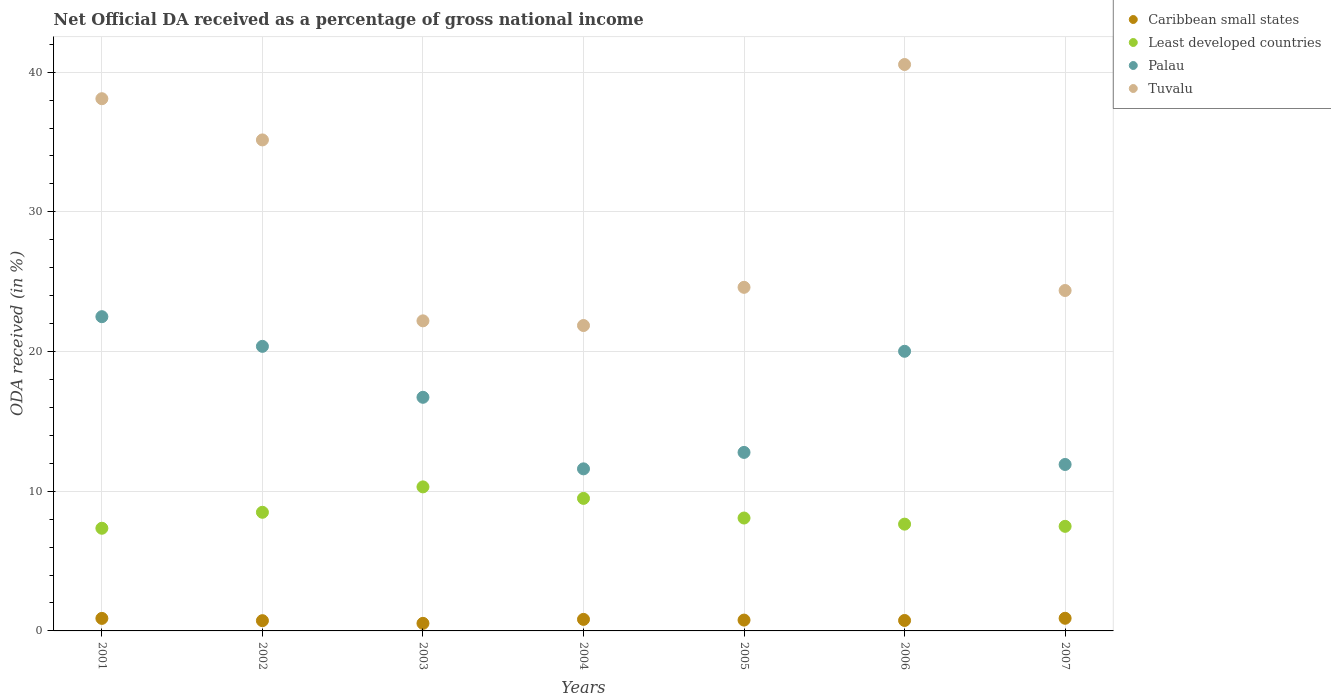Is the number of dotlines equal to the number of legend labels?
Keep it short and to the point. Yes. What is the net official DA received in Tuvalu in 2003?
Keep it short and to the point. 22.2. Across all years, what is the maximum net official DA received in Least developed countries?
Your answer should be compact. 10.31. Across all years, what is the minimum net official DA received in Least developed countries?
Your answer should be very brief. 7.35. What is the total net official DA received in Tuvalu in the graph?
Your answer should be very brief. 206.83. What is the difference between the net official DA received in Tuvalu in 2001 and that in 2005?
Offer a very short reply. 13.5. What is the difference between the net official DA received in Caribbean small states in 2002 and the net official DA received in Least developed countries in 2003?
Your response must be concise. -9.58. What is the average net official DA received in Tuvalu per year?
Your answer should be very brief. 29.55. In the year 2002, what is the difference between the net official DA received in Tuvalu and net official DA received in Palau?
Offer a terse response. 14.78. What is the ratio of the net official DA received in Least developed countries in 2003 to that in 2007?
Your response must be concise. 1.38. What is the difference between the highest and the second highest net official DA received in Caribbean small states?
Offer a terse response. 0.01. What is the difference between the highest and the lowest net official DA received in Tuvalu?
Give a very brief answer. 18.69. Is it the case that in every year, the sum of the net official DA received in Least developed countries and net official DA received in Caribbean small states  is greater than the net official DA received in Tuvalu?
Make the answer very short. No. How many dotlines are there?
Your answer should be compact. 4. Are the values on the major ticks of Y-axis written in scientific E-notation?
Your answer should be very brief. No. Does the graph contain any zero values?
Your response must be concise. No. How many legend labels are there?
Provide a short and direct response. 4. What is the title of the graph?
Your answer should be compact. Net Official DA received as a percentage of gross national income. Does "Gambia, The" appear as one of the legend labels in the graph?
Ensure brevity in your answer.  No. What is the label or title of the Y-axis?
Offer a very short reply. ODA received (in %). What is the ODA received (in %) of Caribbean small states in 2001?
Give a very brief answer. 0.9. What is the ODA received (in %) of Least developed countries in 2001?
Offer a terse response. 7.35. What is the ODA received (in %) in Palau in 2001?
Offer a terse response. 22.5. What is the ODA received (in %) of Tuvalu in 2001?
Keep it short and to the point. 38.1. What is the ODA received (in %) of Caribbean small states in 2002?
Your answer should be very brief. 0.73. What is the ODA received (in %) in Least developed countries in 2002?
Your answer should be very brief. 8.49. What is the ODA received (in %) in Palau in 2002?
Give a very brief answer. 20.37. What is the ODA received (in %) of Tuvalu in 2002?
Offer a terse response. 35.15. What is the ODA received (in %) in Caribbean small states in 2003?
Provide a succinct answer. 0.54. What is the ODA received (in %) of Least developed countries in 2003?
Offer a very short reply. 10.31. What is the ODA received (in %) of Palau in 2003?
Provide a succinct answer. 16.73. What is the ODA received (in %) in Tuvalu in 2003?
Keep it short and to the point. 22.2. What is the ODA received (in %) in Caribbean small states in 2004?
Your response must be concise. 0.83. What is the ODA received (in %) in Least developed countries in 2004?
Offer a very short reply. 9.49. What is the ODA received (in %) of Palau in 2004?
Offer a terse response. 11.6. What is the ODA received (in %) in Tuvalu in 2004?
Your answer should be compact. 21.86. What is the ODA received (in %) in Caribbean small states in 2005?
Give a very brief answer. 0.78. What is the ODA received (in %) of Least developed countries in 2005?
Your response must be concise. 8.08. What is the ODA received (in %) of Palau in 2005?
Offer a very short reply. 12.78. What is the ODA received (in %) of Tuvalu in 2005?
Give a very brief answer. 24.6. What is the ODA received (in %) in Caribbean small states in 2006?
Offer a very short reply. 0.75. What is the ODA received (in %) in Least developed countries in 2006?
Your answer should be very brief. 7.64. What is the ODA received (in %) in Palau in 2006?
Offer a very short reply. 20.02. What is the ODA received (in %) of Tuvalu in 2006?
Provide a short and direct response. 40.55. What is the ODA received (in %) of Caribbean small states in 2007?
Keep it short and to the point. 0.91. What is the ODA received (in %) of Least developed countries in 2007?
Make the answer very short. 7.49. What is the ODA received (in %) of Palau in 2007?
Provide a succinct answer. 11.92. What is the ODA received (in %) in Tuvalu in 2007?
Offer a terse response. 24.37. Across all years, what is the maximum ODA received (in %) of Caribbean small states?
Ensure brevity in your answer.  0.91. Across all years, what is the maximum ODA received (in %) in Least developed countries?
Your answer should be compact. 10.31. Across all years, what is the maximum ODA received (in %) in Palau?
Your response must be concise. 22.5. Across all years, what is the maximum ODA received (in %) of Tuvalu?
Make the answer very short. 40.55. Across all years, what is the minimum ODA received (in %) in Caribbean small states?
Your response must be concise. 0.54. Across all years, what is the minimum ODA received (in %) of Least developed countries?
Keep it short and to the point. 7.35. Across all years, what is the minimum ODA received (in %) of Palau?
Keep it short and to the point. 11.6. Across all years, what is the minimum ODA received (in %) in Tuvalu?
Offer a terse response. 21.86. What is the total ODA received (in %) of Caribbean small states in the graph?
Keep it short and to the point. 5.43. What is the total ODA received (in %) of Least developed countries in the graph?
Ensure brevity in your answer.  58.86. What is the total ODA received (in %) in Palau in the graph?
Offer a very short reply. 115.91. What is the total ODA received (in %) in Tuvalu in the graph?
Provide a short and direct response. 206.83. What is the difference between the ODA received (in %) of Caribbean small states in 2001 and that in 2002?
Your response must be concise. 0.16. What is the difference between the ODA received (in %) of Least developed countries in 2001 and that in 2002?
Offer a very short reply. -1.14. What is the difference between the ODA received (in %) of Palau in 2001 and that in 2002?
Offer a very short reply. 2.12. What is the difference between the ODA received (in %) of Tuvalu in 2001 and that in 2002?
Provide a succinct answer. 2.95. What is the difference between the ODA received (in %) in Caribbean small states in 2001 and that in 2003?
Give a very brief answer. 0.35. What is the difference between the ODA received (in %) in Least developed countries in 2001 and that in 2003?
Provide a succinct answer. -2.96. What is the difference between the ODA received (in %) in Palau in 2001 and that in 2003?
Keep it short and to the point. 5.77. What is the difference between the ODA received (in %) in Tuvalu in 2001 and that in 2003?
Make the answer very short. 15.9. What is the difference between the ODA received (in %) in Caribbean small states in 2001 and that in 2004?
Offer a terse response. 0.07. What is the difference between the ODA received (in %) in Least developed countries in 2001 and that in 2004?
Keep it short and to the point. -2.14. What is the difference between the ODA received (in %) of Palau in 2001 and that in 2004?
Provide a short and direct response. 10.89. What is the difference between the ODA received (in %) in Tuvalu in 2001 and that in 2004?
Keep it short and to the point. 16.24. What is the difference between the ODA received (in %) in Caribbean small states in 2001 and that in 2005?
Give a very brief answer. 0.12. What is the difference between the ODA received (in %) in Least developed countries in 2001 and that in 2005?
Offer a terse response. -0.73. What is the difference between the ODA received (in %) in Palau in 2001 and that in 2005?
Your answer should be very brief. 9.72. What is the difference between the ODA received (in %) of Tuvalu in 2001 and that in 2005?
Ensure brevity in your answer.  13.5. What is the difference between the ODA received (in %) in Caribbean small states in 2001 and that in 2006?
Offer a terse response. 0.15. What is the difference between the ODA received (in %) of Least developed countries in 2001 and that in 2006?
Your answer should be compact. -0.29. What is the difference between the ODA received (in %) of Palau in 2001 and that in 2006?
Make the answer very short. 2.48. What is the difference between the ODA received (in %) of Tuvalu in 2001 and that in 2006?
Your answer should be very brief. -2.45. What is the difference between the ODA received (in %) of Caribbean small states in 2001 and that in 2007?
Provide a succinct answer. -0.01. What is the difference between the ODA received (in %) of Least developed countries in 2001 and that in 2007?
Your answer should be very brief. -0.14. What is the difference between the ODA received (in %) of Palau in 2001 and that in 2007?
Offer a very short reply. 10.58. What is the difference between the ODA received (in %) in Tuvalu in 2001 and that in 2007?
Ensure brevity in your answer.  13.73. What is the difference between the ODA received (in %) of Caribbean small states in 2002 and that in 2003?
Keep it short and to the point. 0.19. What is the difference between the ODA received (in %) in Least developed countries in 2002 and that in 2003?
Offer a terse response. -1.82. What is the difference between the ODA received (in %) in Palau in 2002 and that in 2003?
Give a very brief answer. 3.65. What is the difference between the ODA received (in %) of Tuvalu in 2002 and that in 2003?
Make the answer very short. 12.95. What is the difference between the ODA received (in %) of Caribbean small states in 2002 and that in 2004?
Your answer should be compact. -0.09. What is the difference between the ODA received (in %) in Least developed countries in 2002 and that in 2004?
Provide a succinct answer. -1. What is the difference between the ODA received (in %) in Palau in 2002 and that in 2004?
Your answer should be very brief. 8.77. What is the difference between the ODA received (in %) of Tuvalu in 2002 and that in 2004?
Provide a short and direct response. 13.29. What is the difference between the ODA received (in %) of Caribbean small states in 2002 and that in 2005?
Your response must be concise. -0.04. What is the difference between the ODA received (in %) in Least developed countries in 2002 and that in 2005?
Provide a succinct answer. 0.41. What is the difference between the ODA received (in %) in Palau in 2002 and that in 2005?
Ensure brevity in your answer.  7.59. What is the difference between the ODA received (in %) in Tuvalu in 2002 and that in 2005?
Keep it short and to the point. 10.55. What is the difference between the ODA received (in %) in Caribbean small states in 2002 and that in 2006?
Provide a short and direct response. -0.01. What is the difference between the ODA received (in %) of Least developed countries in 2002 and that in 2006?
Give a very brief answer. 0.85. What is the difference between the ODA received (in %) in Palau in 2002 and that in 2006?
Offer a terse response. 0.35. What is the difference between the ODA received (in %) in Tuvalu in 2002 and that in 2006?
Your answer should be compact. -5.4. What is the difference between the ODA received (in %) of Caribbean small states in 2002 and that in 2007?
Your answer should be very brief. -0.17. What is the difference between the ODA received (in %) in Palau in 2002 and that in 2007?
Provide a succinct answer. 8.46. What is the difference between the ODA received (in %) of Tuvalu in 2002 and that in 2007?
Your answer should be compact. 10.78. What is the difference between the ODA received (in %) of Caribbean small states in 2003 and that in 2004?
Give a very brief answer. -0.28. What is the difference between the ODA received (in %) of Least developed countries in 2003 and that in 2004?
Offer a terse response. 0.82. What is the difference between the ODA received (in %) of Palau in 2003 and that in 2004?
Give a very brief answer. 5.12. What is the difference between the ODA received (in %) in Tuvalu in 2003 and that in 2004?
Give a very brief answer. 0.33. What is the difference between the ODA received (in %) in Caribbean small states in 2003 and that in 2005?
Offer a very short reply. -0.23. What is the difference between the ODA received (in %) in Least developed countries in 2003 and that in 2005?
Make the answer very short. 2.23. What is the difference between the ODA received (in %) of Palau in 2003 and that in 2005?
Provide a succinct answer. 3.95. What is the difference between the ODA received (in %) in Tuvalu in 2003 and that in 2005?
Provide a succinct answer. -2.4. What is the difference between the ODA received (in %) of Caribbean small states in 2003 and that in 2006?
Your answer should be very brief. -0.21. What is the difference between the ODA received (in %) in Least developed countries in 2003 and that in 2006?
Your response must be concise. 2.67. What is the difference between the ODA received (in %) in Palau in 2003 and that in 2006?
Your answer should be very brief. -3.29. What is the difference between the ODA received (in %) in Tuvalu in 2003 and that in 2006?
Your answer should be very brief. -18.35. What is the difference between the ODA received (in %) in Caribbean small states in 2003 and that in 2007?
Offer a very short reply. -0.36. What is the difference between the ODA received (in %) of Least developed countries in 2003 and that in 2007?
Your answer should be very brief. 2.82. What is the difference between the ODA received (in %) of Palau in 2003 and that in 2007?
Ensure brevity in your answer.  4.81. What is the difference between the ODA received (in %) of Tuvalu in 2003 and that in 2007?
Your response must be concise. -2.17. What is the difference between the ODA received (in %) of Caribbean small states in 2004 and that in 2005?
Your answer should be compact. 0.05. What is the difference between the ODA received (in %) of Least developed countries in 2004 and that in 2005?
Your response must be concise. 1.41. What is the difference between the ODA received (in %) of Palau in 2004 and that in 2005?
Give a very brief answer. -1.18. What is the difference between the ODA received (in %) in Tuvalu in 2004 and that in 2005?
Provide a succinct answer. -2.73. What is the difference between the ODA received (in %) in Caribbean small states in 2004 and that in 2006?
Provide a succinct answer. 0.08. What is the difference between the ODA received (in %) in Least developed countries in 2004 and that in 2006?
Provide a short and direct response. 1.84. What is the difference between the ODA received (in %) in Palau in 2004 and that in 2006?
Provide a short and direct response. -8.42. What is the difference between the ODA received (in %) of Tuvalu in 2004 and that in 2006?
Your answer should be compact. -18.69. What is the difference between the ODA received (in %) in Caribbean small states in 2004 and that in 2007?
Provide a succinct answer. -0.08. What is the difference between the ODA received (in %) of Least developed countries in 2004 and that in 2007?
Give a very brief answer. 2. What is the difference between the ODA received (in %) of Palau in 2004 and that in 2007?
Your response must be concise. -0.31. What is the difference between the ODA received (in %) of Tuvalu in 2004 and that in 2007?
Provide a short and direct response. -2.51. What is the difference between the ODA received (in %) in Caribbean small states in 2005 and that in 2006?
Ensure brevity in your answer.  0.03. What is the difference between the ODA received (in %) of Least developed countries in 2005 and that in 2006?
Offer a terse response. 0.44. What is the difference between the ODA received (in %) of Palau in 2005 and that in 2006?
Keep it short and to the point. -7.24. What is the difference between the ODA received (in %) of Tuvalu in 2005 and that in 2006?
Offer a very short reply. -15.95. What is the difference between the ODA received (in %) of Caribbean small states in 2005 and that in 2007?
Your answer should be compact. -0.13. What is the difference between the ODA received (in %) of Least developed countries in 2005 and that in 2007?
Your response must be concise. 0.59. What is the difference between the ODA received (in %) of Palau in 2005 and that in 2007?
Provide a succinct answer. 0.86. What is the difference between the ODA received (in %) in Tuvalu in 2005 and that in 2007?
Your answer should be compact. 0.23. What is the difference between the ODA received (in %) in Caribbean small states in 2006 and that in 2007?
Your answer should be compact. -0.16. What is the difference between the ODA received (in %) in Least developed countries in 2006 and that in 2007?
Your answer should be very brief. 0.16. What is the difference between the ODA received (in %) in Palau in 2006 and that in 2007?
Offer a very short reply. 8.1. What is the difference between the ODA received (in %) in Tuvalu in 2006 and that in 2007?
Offer a very short reply. 16.18. What is the difference between the ODA received (in %) of Caribbean small states in 2001 and the ODA received (in %) of Least developed countries in 2002?
Offer a very short reply. -7.6. What is the difference between the ODA received (in %) in Caribbean small states in 2001 and the ODA received (in %) in Palau in 2002?
Offer a terse response. -19.48. What is the difference between the ODA received (in %) of Caribbean small states in 2001 and the ODA received (in %) of Tuvalu in 2002?
Ensure brevity in your answer.  -34.25. What is the difference between the ODA received (in %) in Least developed countries in 2001 and the ODA received (in %) in Palau in 2002?
Your answer should be compact. -13.02. What is the difference between the ODA received (in %) in Least developed countries in 2001 and the ODA received (in %) in Tuvalu in 2002?
Give a very brief answer. -27.8. What is the difference between the ODA received (in %) of Palau in 2001 and the ODA received (in %) of Tuvalu in 2002?
Provide a short and direct response. -12.65. What is the difference between the ODA received (in %) in Caribbean small states in 2001 and the ODA received (in %) in Least developed countries in 2003?
Provide a short and direct response. -9.41. What is the difference between the ODA received (in %) in Caribbean small states in 2001 and the ODA received (in %) in Palau in 2003?
Offer a very short reply. -15.83. What is the difference between the ODA received (in %) in Caribbean small states in 2001 and the ODA received (in %) in Tuvalu in 2003?
Provide a short and direct response. -21.3. What is the difference between the ODA received (in %) in Least developed countries in 2001 and the ODA received (in %) in Palau in 2003?
Offer a very short reply. -9.38. What is the difference between the ODA received (in %) of Least developed countries in 2001 and the ODA received (in %) of Tuvalu in 2003?
Offer a terse response. -14.85. What is the difference between the ODA received (in %) of Palau in 2001 and the ODA received (in %) of Tuvalu in 2003?
Give a very brief answer. 0.3. What is the difference between the ODA received (in %) in Caribbean small states in 2001 and the ODA received (in %) in Least developed countries in 2004?
Your answer should be compact. -8.59. What is the difference between the ODA received (in %) in Caribbean small states in 2001 and the ODA received (in %) in Palau in 2004?
Provide a succinct answer. -10.71. What is the difference between the ODA received (in %) in Caribbean small states in 2001 and the ODA received (in %) in Tuvalu in 2004?
Provide a succinct answer. -20.97. What is the difference between the ODA received (in %) of Least developed countries in 2001 and the ODA received (in %) of Palau in 2004?
Offer a very short reply. -4.25. What is the difference between the ODA received (in %) in Least developed countries in 2001 and the ODA received (in %) in Tuvalu in 2004?
Your answer should be very brief. -14.51. What is the difference between the ODA received (in %) of Palau in 2001 and the ODA received (in %) of Tuvalu in 2004?
Provide a short and direct response. 0.63. What is the difference between the ODA received (in %) of Caribbean small states in 2001 and the ODA received (in %) of Least developed countries in 2005?
Your response must be concise. -7.19. What is the difference between the ODA received (in %) in Caribbean small states in 2001 and the ODA received (in %) in Palau in 2005?
Provide a short and direct response. -11.88. What is the difference between the ODA received (in %) of Caribbean small states in 2001 and the ODA received (in %) of Tuvalu in 2005?
Offer a terse response. -23.7. What is the difference between the ODA received (in %) in Least developed countries in 2001 and the ODA received (in %) in Palau in 2005?
Provide a short and direct response. -5.43. What is the difference between the ODA received (in %) in Least developed countries in 2001 and the ODA received (in %) in Tuvalu in 2005?
Your answer should be compact. -17.25. What is the difference between the ODA received (in %) in Palau in 2001 and the ODA received (in %) in Tuvalu in 2005?
Keep it short and to the point. -2.1. What is the difference between the ODA received (in %) of Caribbean small states in 2001 and the ODA received (in %) of Least developed countries in 2006?
Give a very brief answer. -6.75. What is the difference between the ODA received (in %) of Caribbean small states in 2001 and the ODA received (in %) of Palau in 2006?
Give a very brief answer. -19.12. What is the difference between the ODA received (in %) in Caribbean small states in 2001 and the ODA received (in %) in Tuvalu in 2006?
Your response must be concise. -39.65. What is the difference between the ODA received (in %) of Least developed countries in 2001 and the ODA received (in %) of Palau in 2006?
Provide a short and direct response. -12.67. What is the difference between the ODA received (in %) of Least developed countries in 2001 and the ODA received (in %) of Tuvalu in 2006?
Offer a very short reply. -33.2. What is the difference between the ODA received (in %) in Palau in 2001 and the ODA received (in %) in Tuvalu in 2006?
Your response must be concise. -18.05. What is the difference between the ODA received (in %) in Caribbean small states in 2001 and the ODA received (in %) in Least developed countries in 2007?
Give a very brief answer. -6.59. What is the difference between the ODA received (in %) of Caribbean small states in 2001 and the ODA received (in %) of Palau in 2007?
Your answer should be compact. -11.02. What is the difference between the ODA received (in %) of Caribbean small states in 2001 and the ODA received (in %) of Tuvalu in 2007?
Your response must be concise. -23.47. What is the difference between the ODA received (in %) of Least developed countries in 2001 and the ODA received (in %) of Palau in 2007?
Offer a very short reply. -4.57. What is the difference between the ODA received (in %) in Least developed countries in 2001 and the ODA received (in %) in Tuvalu in 2007?
Make the answer very short. -17.02. What is the difference between the ODA received (in %) in Palau in 2001 and the ODA received (in %) in Tuvalu in 2007?
Provide a short and direct response. -1.87. What is the difference between the ODA received (in %) of Caribbean small states in 2002 and the ODA received (in %) of Least developed countries in 2003?
Your answer should be compact. -9.58. What is the difference between the ODA received (in %) of Caribbean small states in 2002 and the ODA received (in %) of Palau in 2003?
Your answer should be very brief. -15.99. What is the difference between the ODA received (in %) of Caribbean small states in 2002 and the ODA received (in %) of Tuvalu in 2003?
Your answer should be compact. -21.46. What is the difference between the ODA received (in %) of Least developed countries in 2002 and the ODA received (in %) of Palau in 2003?
Ensure brevity in your answer.  -8.23. What is the difference between the ODA received (in %) of Least developed countries in 2002 and the ODA received (in %) of Tuvalu in 2003?
Make the answer very short. -13.71. What is the difference between the ODA received (in %) in Palau in 2002 and the ODA received (in %) in Tuvalu in 2003?
Make the answer very short. -1.83. What is the difference between the ODA received (in %) in Caribbean small states in 2002 and the ODA received (in %) in Least developed countries in 2004?
Your answer should be very brief. -8.75. What is the difference between the ODA received (in %) in Caribbean small states in 2002 and the ODA received (in %) in Palau in 2004?
Offer a terse response. -10.87. What is the difference between the ODA received (in %) in Caribbean small states in 2002 and the ODA received (in %) in Tuvalu in 2004?
Give a very brief answer. -21.13. What is the difference between the ODA received (in %) in Least developed countries in 2002 and the ODA received (in %) in Palau in 2004?
Give a very brief answer. -3.11. What is the difference between the ODA received (in %) in Least developed countries in 2002 and the ODA received (in %) in Tuvalu in 2004?
Your response must be concise. -13.37. What is the difference between the ODA received (in %) of Palau in 2002 and the ODA received (in %) of Tuvalu in 2004?
Ensure brevity in your answer.  -1.49. What is the difference between the ODA received (in %) in Caribbean small states in 2002 and the ODA received (in %) in Least developed countries in 2005?
Offer a very short reply. -7.35. What is the difference between the ODA received (in %) in Caribbean small states in 2002 and the ODA received (in %) in Palau in 2005?
Ensure brevity in your answer.  -12.05. What is the difference between the ODA received (in %) in Caribbean small states in 2002 and the ODA received (in %) in Tuvalu in 2005?
Provide a succinct answer. -23.86. What is the difference between the ODA received (in %) of Least developed countries in 2002 and the ODA received (in %) of Palau in 2005?
Offer a very short reply. -4.29. What is the difference between the ODA received (in %) of Least developed countries in 2002 and the ODA received (in %) of Tuvalu in 2005?
Give a very brief answer. -16.1. What is the difference between the ODA received (in %) of Palau in 2002 and the ODA received (in %) of Tuvalu in 2005?
Make the answer very short. -4.23. What is the difference between the ODA received (in %) of Caribbean small states in 2002 and the ODA received (in %) of Least developed countries in 2006?
Ensure brevity in your answer.  -6.91. What is the difference between the ODA received (in %) in Caribbean small states in 2002 and the ODA received (in %) in Palau in 2006?
Your answer should be very brief. -19.29. What is the difference between the ODA received (in %) of Caribbean small states in 2002 and the ODA received (in %) of Tuvalu in 2006?
Offer a very short reply. -39.82. What is the difference between the ODA received (in %) of Least developed countries in 2002 and the ODA received (in %) of Palau in 2006?
Offer a terse response. -11.53. What is the difference between the ODA received (in %) of Least developed countries in 2002 and the ODA received (in %) of Tuvalu in 2006?
Provide a short and direct response. -32.06. What is the difference between the ODA received (in %) of Palau in 2002 and the ODA received (in %) of Tuvalu in 2006?
Your answer should be very brief. -20.18. What is the difference between the ODA received (in %) of Caribbean small states in 2002 and the ODA received (in %) of Least developed countries in 2007?
Offer a very short reply. -6.75. What is the difference between the ODA received (in %) in Caribbean small states in 2002 and the ODA received (in %) in Palau in 2007?
Offer a terse response. -11.18. What is the difference between the ODA received (in %) in Caribbean small states in 2002 and the ODA received (in %) in Tuvalu in 2007?
Provide a short and direct response. -23.64. What is the difference between the ODA received (in %) of Least developed countries in 2002 and the ODA received (in %) of Palau in 2007?
Your response must be concise. -3.42. What is the difference between the ODA received (in %) of Least developed countries in 2002 and the ODA received (in %) of Tuvalu in 2007?
Provide a succinct answer. -15.88. What is the difference between the ODA received (in %) in Palau in 2002 and the ODA received (in %) in Tuvalu in 2007?
Provide a succinct answer. -4. What is the difference between the ODA received (in %) in Caribbean small states in 2003 and the ODA received (in %) in Least developed countries in 2004?
Provide a short and direct response. -8.95. What is the difference between the ODA received (in %) of Caribbean small states in 2003 and the ODA received (in %) of Palau in 2004?
Keep it short and to the point. -11.06. What is the difference between the ODA received (in %) of Caribbean small states in 2003 and the ODA received (in %) of Tuvalu in 2004?
Offer a very short reply. -21.32. What is the difference between the ODA received (in %) of Least developed countries in 2003 and the ODA received (in %) of Palau in 2004?
Make the answer very short. -1.29. What is the difference between the ODA received (in %) in Least developed countries in 2003 and the ODA received (in %) in Tuvalu in 2004?
Make the answer very short. -11.55. What is the difference between the ODA received (in %) of Palau in 2003 and the ODA received (in %) of Tuvalu in 2004?
Ensure brevity in your answer.  -5.14. What is the difference between the ODA received (in %) of Caribbean small states in 2003 and the ODA received (in %) of Least developed countries in 2005?
Make the answer very short. -7.54. What is the difference between the ODA received (in %) in Caribbean small states in 2003 and the ODA received (in %) in Palau in 2005?
Offer a terse response. -12.24. What is the difference between the ODA received (in %) of Caribbean small states in 2003 and the ODA received (in %) of Tuvalu in 2005?
Give a very brief answer. -24.06. What is the difference between the ODA received (in %) of Least developed countries in 2003 and the ODA received (in %) of Palau in 2005?
Offer a very short reply. -2.47. What is the difference between the ODA received (in %) of Least developed countries in 2003 and the ODA received (in %) of Tuvalu in 2005?
Your answer should be compact. -14.29. What is the difference between the ODA received (in %) of Palau in 2003 and the ODA received (in %) of Tuvalu in 2005?
Offer a terse response. -7.87. What is the difference between the ODA received (in %) in Caribbean small states in 2003 and the ODA received (in %) in Least developed countries in 2006?
Your answer should be very brief. -7.1. What is the difference between the ODA received (in %) of Caribbean small states in 2003 and the ODA received (in %) of Palau in 2006?
Offer a very short reply. -19.48. What is the difference between the ODA received (in %) in Caribbean small states in 2003 and the ODA received (in %) in Tuvalu in 2006?
Make the answer very short. -40.01. What is the difference between the ODA received (in %) in Least developed countries in 2003 and the ODA received (in %) in Palau in 2006?
Make the answer very short. -9.71. What is the difference between the ODA received (in %) in Least developed countries in 2003 and the ODA received (in %) in Tuvalu in 2006?
Give a very brief answer. -30.24. What is the difference between the ODA received (in %) in Palau in 2003 and the ODA received (in %) in Tuvalu in 2006?
Your answer should be compact. -23.82. What is the difference between the ODA received (in %) in Caribbean small states in 2003 and the ODA received (in %) in Least developed countries in 2007?
Make the answer very short. -6.95. What is the difference between the ODA received (in %) in Caribbean small states in 2003 and the ODA received (in %) in Palau in 2007?
Your response must be concise. -11.37. What is the difference between the ODA received (in %) of Caribbean small states in 2003 and the ODA received (in %) of Tuvalu in 2007?
Provide a succinct answer. -23.83. What is the difference between the ODA received (in %) of Least developed countries in 2003 and the ODA received (in %) of Palau in 2007?
Provide a short and direct response. -1.6. What is the difference between the ODA received (in %) in Least developed countries in 2003 and the ODA received (in %) in Tuvalu in 2007?
Make the answer very short. -14.06. What is the difference between the ODA received (in %) in Palau in 2003 and the ODA received (in %) in Tuvalu in 2007?
Ensure brevity in your answer.  -7.65. What is the difference between the ODA received (in %) of Caribbean small states in 2004 and the ODA received (in %) of Least developed countries in 2005?
Your answer should be compact. -7.26. What is the difference between the ODA received (in %) of Caribbean small states in 2004 and the ODA received (in %) of Palau in 2005?
Give a very brief answer. -11.95. What is the difference between the ODA received (in %) of Caribbean small states in 2004 and the ODA received (in %) of Tuvalu in 2005?
Keep it short and to the point. -23.77. What is the difference between the ODA received (in %) in Least developed countries in 2004 and the ODA received (in %) in Palau in 2005?
Your response must be concise. -3.29. What is the difference between the ODA received (in %) in Least developed countries in 2004 and the ODA received (in %) in Tuvalu in 2005?
Give a very brief answer. -15.11. What is the difference between the ODA received (in %) of Palau in 2004 and the ODA received (in %) of Tuvalu in 2005?
Give a very brief answer. -13. What is the difference between the ODA received (in %) in Caribbean small states in 2004 and the ODA received (in %) in Least developed countries in 2006?
Your response must be concise. -6.82. What is the difference between the ODA received (in %) in Caribbean small states in 2004 and the ODA received (in %) in Palau in 2006?
Offer a terse response. -19.19. What is the difference between the ODA received (in %) of Caribbean small states in 2004 and the ODA received (in %) of Tuvalu in 2006?
Provide a succinct answer. -39.72. What is the difference between the ODA received (in %) of Least developed countries in 2004 and the ODA received (in %) of Palau in 2006?
Keep it short and to the point. -10.53. What is the difference between the ODA received (in %) in Least developed countries in 2004 and the ODA received (in %) in Tuvalu in 2006?
Your response must be concise. -31.06. What is the difference between the ODA received (in %) of Palau in 2004 and the ODA received (in %) of Tuvalu in 2006?
Offer a very short reply. -28.95. What is the difference between the ODA received (in %) in Caribbean small states in 2004 and the ODA received (in %) in Least developed countries in 2007?
Your answer should be very brief. -6.66. What is the difference between the ODA received (in %) of Caribbean small states in 2004 and the ODA received (in %) of Palau in 2007?
Your response must be concise. -11.09. What is the difference between the ODA received (in %) of Caribbean small states in 2004 and the ODA received (in %) of Tuvalu in 2007?
Keep it short and to the point. -23.54. What is the difference between the ODA received (in %) of Least developed countries in 2004 and the ODA received (in %) of Palau in 2007?
Make the answer very short. -2.43. What is the difference between the ODA received (in %) of Least developed countries in 2004 and the ODA received (in %) of Tuvalu in 2007?
Your answer should be compact. -14.88. What is the difference between the ODA received (in %) in Palau in 2004 and the ODA received (in %) in Tuvalu in 2007?
Your answer should be very brief. -12.77. What is the difference between the ODA received (in %) of Caribbean small states in 2005 and the ODA received (in %) of Least developed countries in 2006?
Ensure brevity in your answer.  -6.87. What is the difference between the ODA received (in %) of Caribbean small states in 2005 and the ODA received (in %) of Palau in 2006?
Make the answer very short. -19.24. What is the difference between the ODA received (in %) of Caribbean small states in 2005 and the ODA received (in %) of Tuvalu in 2006?
Provide a short and direct response. -39.77. What is the difference between the ODA received (in %) in Least developed countries in 2005 and the ODA received (in %) in Palau in 2006?
Keep it short and to the point. -11.94. What is the difference between the ODA received (in %) in Least developed countries in 2005 and the ODA received (in %) in Tuvalu in 2006?
Your answer should be very brief. -32.47. What is the difference between the ODA received (in %) of Palau in 2005 and the ODA received (in %) of Tuvalu in 2006?
Keep it short and to the point. -27.77. What is the difference between the ODA received (in %) of Caribbean small states in 2005 and the ODA received (in %) of Least developed countries in 2007?
Give a very brief answer. -6.71. What is the difference between the ODA received (in %) in Caribbean small states in 2005 and the ODA received (in %) in Palau in 2007?
Ensure brevity in your answer.  -11.14. What is the difference between the ODA received (in %) of Caribbean small states in 2005 and the ODA received (in %) of Tuvalu in 2007?
Provide a succinct answer. -23.59. What is the difference between the ODA received (in %) of Least developed countries in 2005 and the ODA received (in %) of Palau in 2007?
Provide a succinct answer. -3.83. What is the difference between the ODA received (in %) of Least developed countries in 2005 and the ODA received (in %) of Tuvalu in 2007?
Your answer should be very brief. -16.29. What is the difference between the ODA received (in %) of Palau in 2005 and the ODA received (in %) of Tuvalu in 2007?
Your answer should be very brief. -11.59. What is the difference between the ODA received (in %) of Caribbean small states in 2006 and the ODA received (in %) of Least developed countries in 2007?
Offer a very short reply. -6.74. What is the difference between the ODA received (in %) of Caribbean small states in 2006 and the ODA received (in %) of Palau in 2007?
Provide a short and direct response. -11.17. What is the difference between the ODA received (in %) of Caribbean small states in 2006 and the ODA received (in %) of Tuvalu in 2007?
Give a very brief answer. -23.62. What is the difference between the ODA received (in %) in Least developed countries in 2006 and the ODA received (in %) in Palau in 2007?
Your answer should be very brief. -4.27. What is the difference between the ODA received (in %) of Least developed countries in 2006 and the ODA received (in %) of Tuvalu in 2007?
Offer a terse response. -16.73. What is the difference between the ODA received (in %) of Palau in 2006 and the ODA received (in %) of Tuvalu in 2007?
Your answer should be compact. -4.35. What is the average ODA received (in %) in Caribbean small states per year?
Offer a very short reply. 0.78. What is the average ODA received (in %) of Least developed countries per year?
Offer a terse response. 8.41. What is the average ODA received (in %) in Palau per year?
Offer a terse response. 16.56. What is the average ODA received (in %) of Tuvalu per year?
Give a very brief answer. 29.55. In the year 2001, what is the difference between the ODA received (in %) of Caribbean small states and ODA received (in %) of Least developed countries?
Offer a very short reply. -6.45. In the year 2001, what is the difference between the ODA received (in %) of Caribbean small states and ODA received (in %) of Palau?
Keep it short and to the point. -21.6. In the year 2001, what is the difference between the ODA received (in %) of Caribbean small states and ODA received (in %) of Tuvalu?
Offer a terse response. -37.2. In the year 2001, what is the difference between the ODA received (in %) in Least developed countries and ODA received (in %) in Palau?
Offer a very short reply. -15.15. In the year 2001, what is the difference between the ODA received (in %) in Least developed countries and ODA received (in %) in Tuvalu?
Provide a short and direct response. -30.75. In the year 2001, what is the difference between the ODA received (in %) in Palau and ODA received (in %) in Tuvalu?
Make the answer very short. -15.6. In the year 2002, what is the difference between the ODA received (in %) of Caribbean small states and ODA received (in %) of Least developed countries?
Offer a very short reply. -7.76. In the year 2002, what is the difference between the ODA received (in %) in Caribbean small states and ODA received (in %) in Palau?
Offer a very short reply. -19.64. In the year 2002, what is the difference between the ODA received (in %) of Caribbean small states and ODA received (in %) of Tuvalu?
Your answer should be very brief. -34.42. In the year 2002, what is the difference between the ODA received (in %) in Least developed countries and ODA received (in %) in Palau?
Offer a terse response. -11.88. In the year 2002, what is the difference between the ODA received (in %) in Least developed countries and ODA received (in %) in Tuvalu?
Your answer should be very brief. -26.66. In the year 2002, what is the difference between the ODA received (in %) of Palau and ODA received (in %) of Tuvalu?
Offer a very short reply. -14.78. In the year 2003, what is the difference between the ODA received (in %) in Caribbean small states and ODA received (in %) in Least developed countries?
Give a very brief answer. -9.77. In the year 2003, what is the difference between the ODA received (in %) in Caribbean small states and ODA received (in %) in Palau?
Offer a terse response. -16.18. In the year 2003, what is the difference between the ODA received (in %) of Caribbean small states and ODA received (in %) of Tuvalu?
Your response must be concise. -21.66. In the year 2003, what is the difference between the ODA received (in %) of Least developed countries and ODA received (in %) of Palau?
Give a very brief answer. -6.41. In the year 2003, what is the difference between the ODA received (in %) of Least developed countries and ODA received (in %) of Tuvalu?
Your answer should be compact. -11.89. In the year 2003, what is the difference between the ODA received (in %) of Palau and ODA received (in %) of Tuvalu?
Ensure brevity in your answer.  -5.47. In the year 2004, what is the difference between the ODA received (in %) in Caribbean small states and ODA received (in %) in Least developed countries?
Give a very brief answer. -8.66. In the year 2004, what is the difference between the ODA received (in %) in Caribbean small states and ODA received (in %) in Palau?
Offer a very short reply. -10.78. In the year 2004, what is the difference between the ODA received (in %) of Caribbean small states and ODA received (in %) of Tuvalu?
Your response must be concise. -21.04. In the year 2004, what is the difference between the ODA received (in %) in Least developed countries and ODA received (in %) in Palau?
Provide a succinct answer. -2.11. In the year 2004, what is the difference between the ODA received (in %) in Least developed countries and ODA received (in %) in Tuvalu?
Offer a terse response. -12.38. In the year 2004, what is the difference between the ODA received (in %) in Palau and ODA received (in %) in Tuvalu?
Keep it short and to the point. -10.26. In the year 2005, what is the difference between the ODA received (in %) in Caribbean small states and ODA received (in %) in Least developed countries?
Provide a short and direct response. -7.31. In the year 2005, what is the difference between the ODA received (in %) of Caribbean small states and ODA received (in %) of Palau?
Ensure brevity in your answer.  -12. In the year 2005, what is the difference between the ODA received (in %) of Caribbean small states and ODA received (in %) of Tuvalu?
Your response must be concise. -23.82. In the year 2005, what is the difference between the ODA received (in %) of Least developed countries and ODA received (in %) of Palau?
Offer a very short reply. -4.7. In the year 2005, what is the difference between the ODA received (in %) in Least developed countries and ODA received (in %) in Tuvalu?
Keep it short and to the point. -16.52. In the year 2005, what is the difference between the ODA received (in %) of Palau and ODA received (in %) of Tuvalu?
Offer a terse response. -11.82. In the year 2006, what is the difference between the ODA received (in %) in Caribbean small states and ODA received (in %) in Least developed countries?
Make the answer very short. -6.9. In the year 2006, what is the difference between the ODA received (in %) in Caribbean small states and ODA received (in %) in Palau?
Provide a short and direct response. -19.27. In the year 2006, what is the difference between the ODA received (in %) in Caribbean small states and ODA received (in %) in Tuvalu?
Offer a very short reply. -39.8. In the year 2006, what is the difference between the ODA received (in %) of Least developed countries and ODA received (in %) of Palau?
Ensure brevity in your answer.  -12.37. In the year 2006, what is the difference between the ODA received (in %) in Least developed countries and ODA received (in %) in Tuvalu?
Offer a terse response. -32.9. In the year 2006, what is the difference between the ODA received (in %) of Palau and ODA received (in %) of Tuvalu?
Make the answer very short. -20.53. In the year 2007, what is the difference between the ODA received (in %) of Caribbean small states and ODA received (in %) of Least developed countries?
Offer a terse response. -6.58. In the year 2007, what is the difference between the ODA received (in %) of Caribbean small states and ODA received (in %) of Palau?
Provide a succinct answer. -11.01. In the year 2007, what is the difference between the ODA received (in %) of Caribbean small states and ODA received (in %) of Tuvalu?
Give a very brief answer. -23.46. In the year 2007, what is the difference between the ODA received (in %) in Least developed countries and ODA received (in %) in Palau?
Give a very brief answer. -4.43. In the year 2007, what is the difference between the ODA received (in %) in Least developed countries and ODA received (in %) in Tuvalu?
Your response must be concise. -16.88. In the year 2007, what is the difference between the ODA received (in %) in Palau and ODA received (in %) in Tuvalu?
Provide a succinct answer. -12.45. What is the ratio of the ODA received (in %) in Caribbean small states in 2001 to that in 2002?
Provide a short and direct response. 1.22. What is the ratio of the ODA received (in %) of Least developed countries in 2001 to that in 2002?
Make the answer very short. 0.87. What is the ratio of the ODA received (in %) of Palau in 2001 to that in 2002?
Your answer should be very brief. 1.1. What is the ratio of the ODA received (in %) of Tuvalu in 2001 to that in 2002?
Your answer should be very brief. 1.08. What is the ratio of the ODA received (in %) in Caribbean small states in 2001 to that in 2003?
Offer a terse response. 1.65. What is the ratio of the ODA received (in %) of Least developed countries in 2001 to that in 2003?
Provide a short and direct response. 0.71. What is the ratio of the ODA received (in %) of Palau in 2001 to that in 2003?
Make the answer very short. 1.35. What is the ratio of the ODA received (in %) in Tuvalu in 2001 to that in 2003?
Your response must be concise. 1.72. What is the ratio of the ODA received (in %) in Caribbean small states in 2001 to that in 2004?
Provide a short and direct response. 1.09. What is the ratio of the ODA received (in %) in Least developed countries in 2001 to that in 2004?
Your response must be concise. 0.77. What is the ratio of the ODA received (in %) in Palau in 2001 to that in 2004?
Offer a very short reply. 1.94. What is the ratio of the ODA received (in %) of Tuvalu in 2001 to that in 2004?
Ensure brevity in your answer.  1.74. What is the ratio of the ODA received (in %) in Caribbean small states in 2001 to that in 2005?
Give a very brief answer. 1.16. What is the ratio of the ODA received (in %) in Least developed countries in 2001 to that in 2005?
Offer a very short reply. 0.91. What is the ratio of the ODA received (in %) of Palau in 2001 to that in 2005?
Offer a terse response. 1.76. What is the ratio of the ODA received (in %) in Tuvalu in 2001 to that in 2005?
Your answer should be very brief. 1.55. What is the ratio of the ODA received (in %) of Caribbean small states in 2001 to that in 2006?
Your response must be concise. 1.2. What is the ratio of the ODA received (in %) in Least developed countries in 2001 to that in 2006?
Provide a short and direct response. 0.96. What is the ratio of the ODA received (in %) of Palau in 2001 to that in 2006?
Give a very brief answer. 1.12. What is the ratio of the ODA received (in %) of Tuvalu in 2001 to that in 2006?
Your response must be concise. 0.94. What is the ratio of the ODA received (in %) of Caribbean small states in 2001 to that in 2007?
Provide a short and direct response. 0.99. What is the ratio of the ODA received (in %) of Least developed countries in 2001 to that in 2007?
Provide a succinct answer. 0.98. What is the ratio of the ODA received (in %) in Palau in 2001 to that in 2007?
Your answer should be compact. 1.89. What is the ratio of the ODA received (in %) in Tuvalu in 2001 to that in 2007?
Your response must be concise. 1.56. What is the ratio of the ODA received (in %) in Caribbean small states in 2002 to that in 2003?
Offer a terse response. 1.35. What is the ratio of the ODA received (in %) of Least developed countries in 2002 to that in 2003?
Your response must be concise. 0.82. What is the ratio of the ODA received (in %) in Palau in 2002 to that in 2003?
Your response must be concise. 1.22. What is the ratio of the ODA received (in %) of Tuvalu in 2002 to that in 2003?
Ensure brevity in your answer.  1.58. What is the ratio of the ODA received (in %) in Caribbean small states in 2002 to that in 2004?
Ensure brevity in your answer.  0.89. What is the ratio of the ODA received (in %) in Least developed countries in 2002 to that in 2004?
Your response must be concise. 0.9. What is the ratio of the ODA received (in %) of Palau in 2002 to that in 2004?
Your answer should be compact. 1.76. What is the ratio of the ODA received (in %) of Tuvalu in 2002 to that in 2004?
Offer a very short reply. 1.61. What is the ratio of the ODA received (in %) in Caribbean small states in 2002 to that in 2005?
Provide a short and direct response. 0.95. What is the ratio of the ODA received (in %) in Least developed countries in 2002 to that in 2005?
Your answer should be compact. 1.05. What is the ratio of the ODA received (in %) of Palau in 2002 to that in 2005?
Give a very brief answer. 1.59. What is the ratio of the ODA received (in %) of Tuvalu in 2002 to that in 2005?
Provide a succinct answer. 1.43. What is the ratio of the ODA received (in %) of Caribbean small states in 2002 to that in 2006?
Offer a very short reply. 0.98. What is the ratio of the ODA received (in %) of Least developed countries in 2002 to that in 2006?
Provide a short and direct response. 1.11. What is the ratio of the ODA received (in %) in Palau in 2002 to that in 2006?
Ensure brevity in your answer.  1.02. What is the ratio of the ODA received (in %) in Tuvalu in 2002 to that in 2006?
Make the answer very short. 0.87. What is the ratio of the ODA received (in %) of Caribbean small states in 2002 to that in 2007?
Offer a terse response. 0.81. What is the ratio of the ODA received (in %) in Least developed countries in 2002 to that in 2007?
Your answer should be compact. 1.13. What is the ratio of the ODA received (in %) of Palau in 2002 to that in 2007?
Provide a succinct answer. 1.71. What is the ratio of the ODA received (in %) of Tuvalu in 2002 to that in 2007?
Give a very brief answer. 1.44. What is the ratio of the ODA received (in %) in Caribbean small states in 2003 to that in 2004?
Your answer should be very brief. 0.66. What is the ratio of the ODA received (in %) of Least developed countries in 2003 to that in 2004?
Your answer should be very brief. 1.09. What is the ratio of the ODA received (in %) in Palau in 2003 to that in 2004?
Your response must be concise. 1.44. What is the ratio of the ODA received (in %) in Tuvalu in 2003 to that in 2004?
Your response must be concise. 1.02. What is the ratio of the ODA received (in %) in Caribbean small states in 2003 to that in 2005?
Provide a succinct answer. 0.7. What is the ratio of the ODA received (in %) of Least developed countries in 2003 to that in 2005?
Give a very brief answer. 1.28. What is the ratio of the ODA received (in %) in Palau in 2003 to that in 2005?
Your answer should be very brief. 1.31. What is the ratio of the ODA received (in %) in Tuvalu in 2003 to that in 2005?
Provide a succinct answer. 0.9. What is the ratio of the ODA received (in %) of Caribbean small states in 2003 to that in 2006?
Your answer should be very brief. 0.72. What is the ratio of the ODA received (in %) of Least developed countries in 2003 to that in 2006?
Keep it short and to the point. 1.35. What is the ratio of the ODA received (in %) in Palau in 2003 to that in 2006?
Make the answer very short. 0.84. What is the ratio of the ODA received (in %) in Tuvalu in 2003 to that in 2006?
Your answer should be compact. 0.55. What is the ratio of the ODA received (in %) in Caribbean small states in 2003 to that in 2007?
Ensure brevity in your answer.  0.6. What is the ratio of the ODA received (in %) in Least developed countries in 2003 to that in 2007?
Your response must be concise. 1.38. What is the ratio of the ODA received (in %) of Palau in 2003 to that in 2007?
Keep it short and to the point. 1.4. What is the ratio of the ODA received (in %) in Tuvalu in 2003 to that in 2007?
Provide a succinct answer. 0.91. What is the ratio of the ODA received (in %) of Caribbean small states in 2004 to that in 2005?
Your response must be concise. 1.07. What is the ratio of the ODA received (in %) of Least developed countries in 2004 to that in 2005?
Provide a short and direct response. 1.17. What is the ratio of the ODA received (in %) in Palau in 2004 to that in 2005?
Offer a terse response. 0.91. What is the ratio of the ODA received (in %) in Tuvalu in 2004 to that in 2005?
Make the answer very short. 0.89. What is the ratio of the ODA received (in %) in Caribbean small states in 2004 to that in 2006?
Your answer should be compact. 1.1. What is the ratio of the ODA received (in %) in Least developed countries in 2004 to that in 2006?
Ensure brevity in your answer.  1.24. What is the ratio of the ODA received (in %) of Palau in 2004 to that in 2006?
Your answer should be very brief. 0.58. What is the ratio of the ODA received (in %) of Tuvalu in 2004 to that in 2006?
Ensure brevity in your answer.  0.54. What is the ratio of the ODA received (in %) of Caribbean small states in 2004 to that in 2007?
Keep it short and to the point. 0.91. What is the ratio of the ODA received (in %) of Least developed countries in 2004 to that in 2007?
Your answer should be very brief. 1.27. What is the ratio of the ODA received (in %) of Palau in 2004 to that in 2007?
Ensure brevity in your answer.  0.97. What is the ratio of the ODA received (in %) of Tuvalu in 2004 to that in 2007?
Ensure brevity in your answer.  0.9. What is the ratio of the ODA received (in %) of Caribbean small states in 2005 to that in 2006?
Your answer should be very brief. 1.04. What is the ratio of the ODA received (in %) of Least developed countries in 2005 to that in 2006?
Your response must be concise. 1.06. What is the ratio of the ODA received (in %) of Palau in 2005 to that in 2006?
Provide a short and direct response. 0.64. What is the ratio of the ODA received (in %) in Tuvalu in 2005 to that in 2006?
Make the answer very short. 0.61. What is the ratio of the ODA received (in %) of Caribbean small states in 2005 to that in 2007?
Offer a very short reply. 0.86. What is the ratio of the ODA received (in %) in Least developed countries in 2005 to that in 2007?
Provide a short and direct response. 1.08. What is the ratio of the ODA received (in %) in Palau in 2005 to that in 2007?
Keep it short and to the point. 1.07. What is the ratio of the ODA received (in %) of Tuvalu in 2005 to that in 2007?
Your answer should be compact. 1.01. What is the ratio of the ODA received (in %) in Caribbean small states in 2006 to that in 2007?
Your response must be concise. 0.83. What is the ratio of the ODA received (in %) of Least developed countries in 2006 to that in 2007?
Make the answer very short. 1.02. What is the ratio of the ODA received (in %) in Palau in 2006 to that in 2007?
Provide a succinct answer. 1.68. What is the ratio of the ODA received (in %) of Tuvalu in 2006 to that in 2007?
Provide a short and direct response. 1.66. What is the difference between the highest and the second highest ODA received (in %) in Caribbean small states?
Offer a terse response. 0.01. What is the difference between the highest and the second highest ODA received (in %) of Least developed countries?
Your answer should be compact. 0.82. What is the difference between the highest and the second highest ODA received (in %) of Palau?
Your answer should be very brief. 2.12. What is the difference between the highest and the second highest ODA received (in %) in Tuvalu?
Provide a short and direct response. 2.45. What is the difference between the highest and the lowest ODA received (in %) in Caribbean small states?
Keep it short and to the point. 0.36. What is the difference between the highest and the lowest ODA received (in %) in Least developed countries?
Give a very brief answer. 2.96. What is the difference between the highest and the lowest ODA received (in %) in Palau?
Make the answer very short. 10.89. What is the difference between the highest and the lowest ODA received (in %) of Tuvalu?
Offer a very short reply. 18.69. 